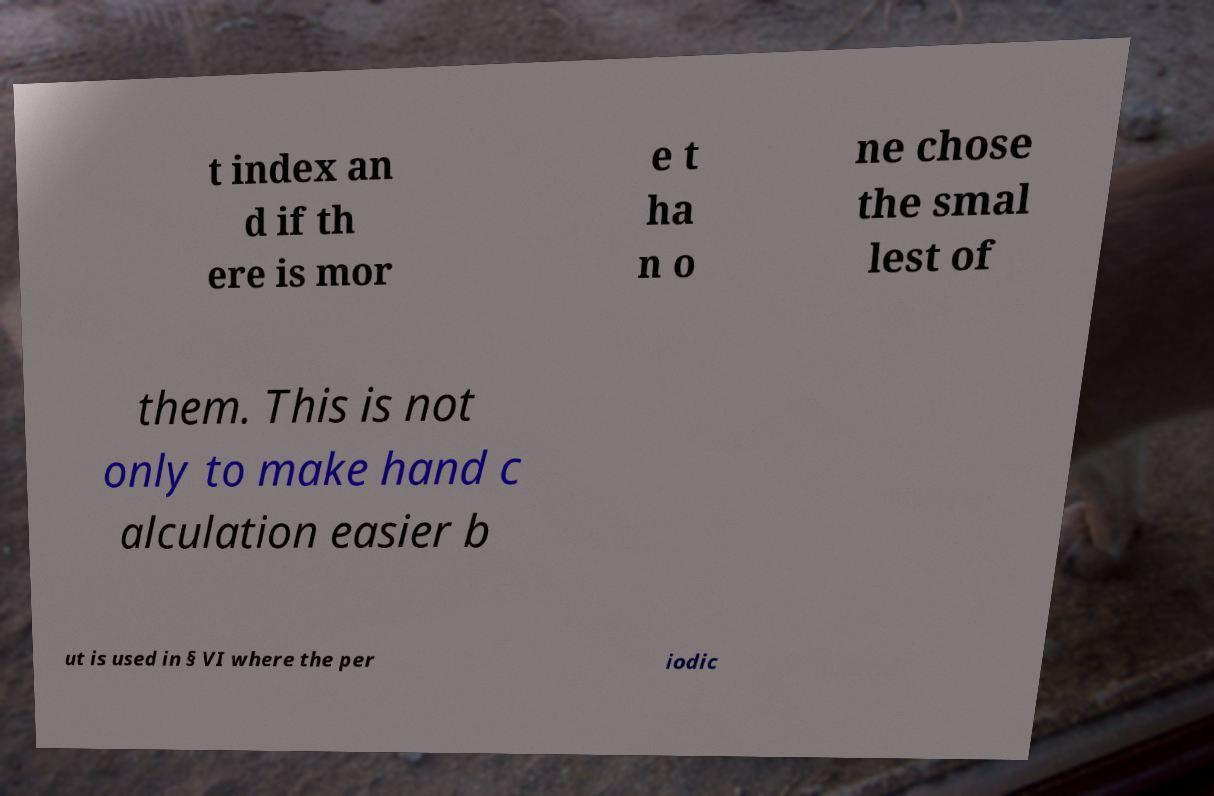What messages or text are displayed in this image? I need them in a readable, typed format. t index an d if th ere is mor e t ha n o ne chose the smal lest of them. This is not only to make hand c alculation easier b ut is used in § VI where the per iodic 